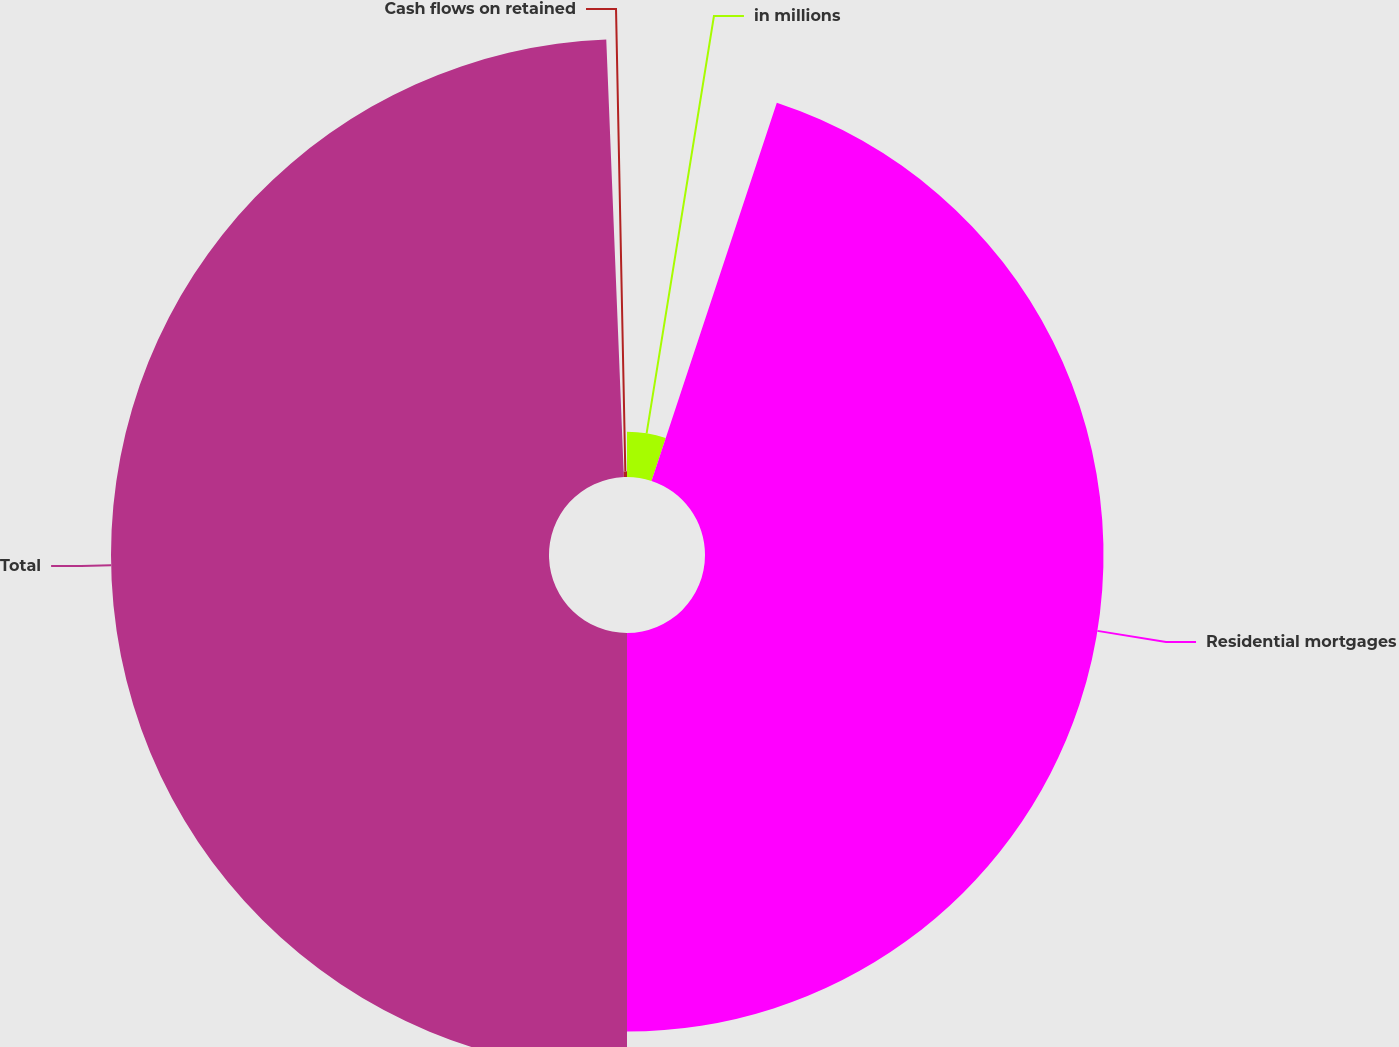Convert chart. <chart><loc_0><loc_0><loc_500><loc_500><pie_chart><fcel>in millions<fcel>Residential mortgages<fcel>Total<fcel>Cash flows on retained<nl><fcel>5.09%<fcel>44.91%<fcel>49.36%<fcel>0.64%<nl></chart> 